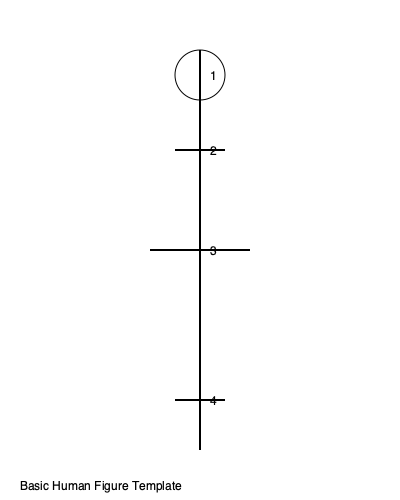In costume design, the basic human figure is often divided into proportional segments for accurate measurements. Using the provided template, what is the ideal ratio of the total figure height to the head height (segment 1)? To determine the ideal ratio of total figure height to head height in costume design, we need to follow these steps:

1. Understand the standard proportions:
   In classical figure drawing and costume design, the human body is typically divided into 8 equal parts, with the head being one of these parts.

2. Analyze the given template:
   The template shows 4 key segments of the human figure:
   1 - Head
   2 - Shoulders to chest
   3 - Waist
   4 - Legs

3. Identify the head height:
   Segment 1 represents the head height in the template.

4. Calculate the total figure height:
   The total figure height is the sum of all segments, which is 8 times the head height.

5. Express the ratio:
   The ratio of total figure height to head height can be expressed as:
   $$ \frac{\text{Total Height}}{\text{Head Height}} = \frac{8 \times \text{Head Height}}{\text{Head Height}} = 8:1 $$

This 8:1 ratio is widely used in costume design as it provides a balanced and aesthetically pleasing representation of the human form.
Answer: 8:1 